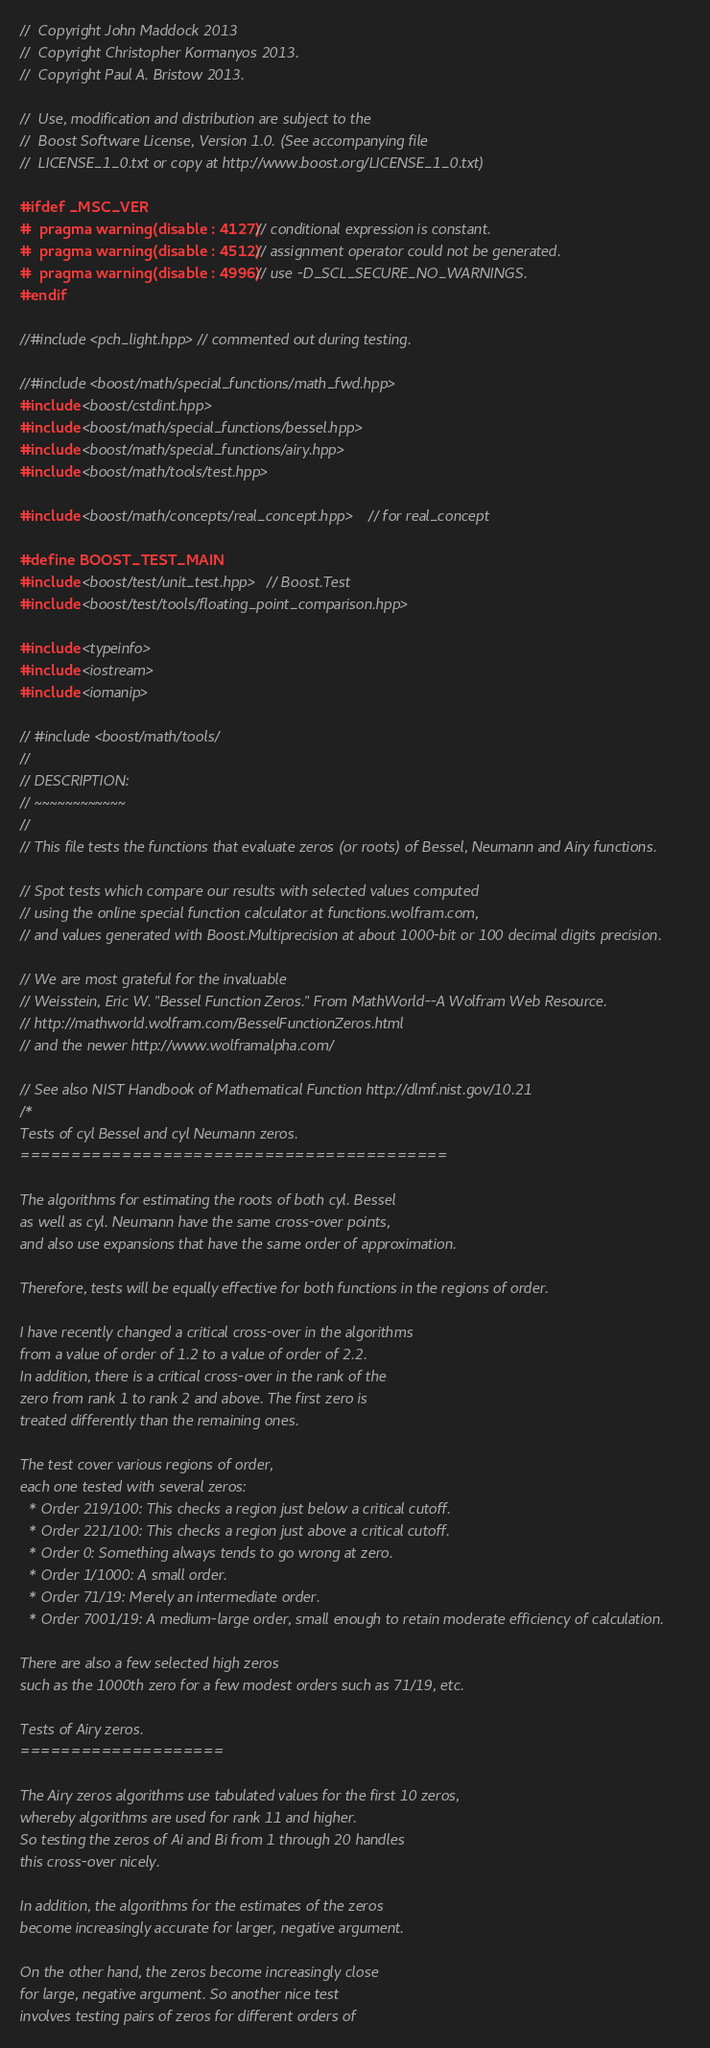<code> <loc_0><loc_0><loc_500><loc_500><_C++_>//  Copyright John Maddock 2013
//  Copyright Christopher Kormanyos 2013.
//  Copyright Paul A. Bristow 2013.

//  Use, modification and distribution are subject to the
//  Boost Software License, Version 1.0. (See accompanying file
//  LICENSE_1_0.txt or copy at http://www.boost.org/LICENSE_1_0.txt)

#ifdef _MSC_VER
#  pragma warning(disable : 4127) // conditional expression is constant.
#  pragma warning(disable : 4512) // assignment operator could not be generated.
#  pragma warning(disable : 4996) // use -D_SCL_SECURE_NO_WARNINGS.
#endif

//#include <pch_light.hpp> // commented out during testing.

//#include <boost/math/special_functions/math_fwd.hpp>
#include <boost/cstdint.hpp>
#include <boost/math/special_functions/bessel.hpp>
#include <boost/math/special_functions/airy.hpp>
#include <boost/math/tools/test.hpp>

#include <boost/math/concepts/real_concept.hpp> // for real_concept

#define BOOST_TEST_MAIN
#include <boost/test/unit_test.hpp> // Boost.Test
#include <boost/test/tools/floating_point_comparison.hpp>

#include <typeinfo>
#include <iostream>
#include <iomanip>

// #include <boost/math/tools/
//
// DESCRIPTION:
// ~~~~~~~~~~~~
//
// This file tests the functions that evaluate zeros (or roots) of Bessel, Neumann and Airy functions.

// Spot tests which compare our results with selected values computed
// using the online special function calculator at functions.wolfram.com,
// and values generated with Boost.Multiprecision at about 1000-bit or 100 decimal digits precision.

// We are most grateful for the invaluable
// Weisstein, Eric W. "Bessel Function Zeros." From MathWorld--A Wolfram Web Resource.
// http://mathworld.wolfram.com/BesselFunctionZeros.html
// and the newer http://www.wolframalpha.com/

// See also NIST Handbook of Mathematical Function http://dlmf.nist.gov/10.21
/*
Tests of cyl Bessel and cyl Neumann zeros.
==========================================

The algorithms for estimating the roots of both cyl. Bessel
as well as cyl. Neumann have the same cross-over points,
and also use expansions that have the same order of approximation.

Therefore, tests will be equally effective for both functions in the regions of order.

I have recently changed a critical cross-over in the algorithms
from a value of order of 1.2 to a value of order of 2.2.
In addition, there is a critical cross-over in the rank of the
zero from rank 1 to rank 2 and above. The first zero is
treated differently than the remaining ones.

The test cover various regions of order,
each one tested with several zeros:
  * Order 219/100: This checks a region just below a critical cutoff.
  * Order 221/100: This checks a region just above a critical cutoff.
  * Order 0: Something always tends to go wrong at zero.
  * Order 1/1000: A small order.
  * Order 71/19: Merely an intermediate order.
  * Order 7001/19: A medium-large order, small enough to retain moderate efficiency of calculation.

There are also a few selected high zeros
such as the 1000th zero for a few modest orders such as 71/19, etc.

Tests of Airy zeros.
====================

The Airy zeros algorithms use tabulated values for the first 10 zeros,
whereby algorithms are used for rank 11 and higher.
So testing the zeros of Ai and Bi from 1 through 20 handles
this cross-over nicely.

In addition, the algorithms for the estimates of the zeros
become increasingly accurate for larger, negative argument.

On the other hand, the zeros become increasingly close
for large, negative argument. So another nice test
involves testing pairs of zeros for different orders of</code> 